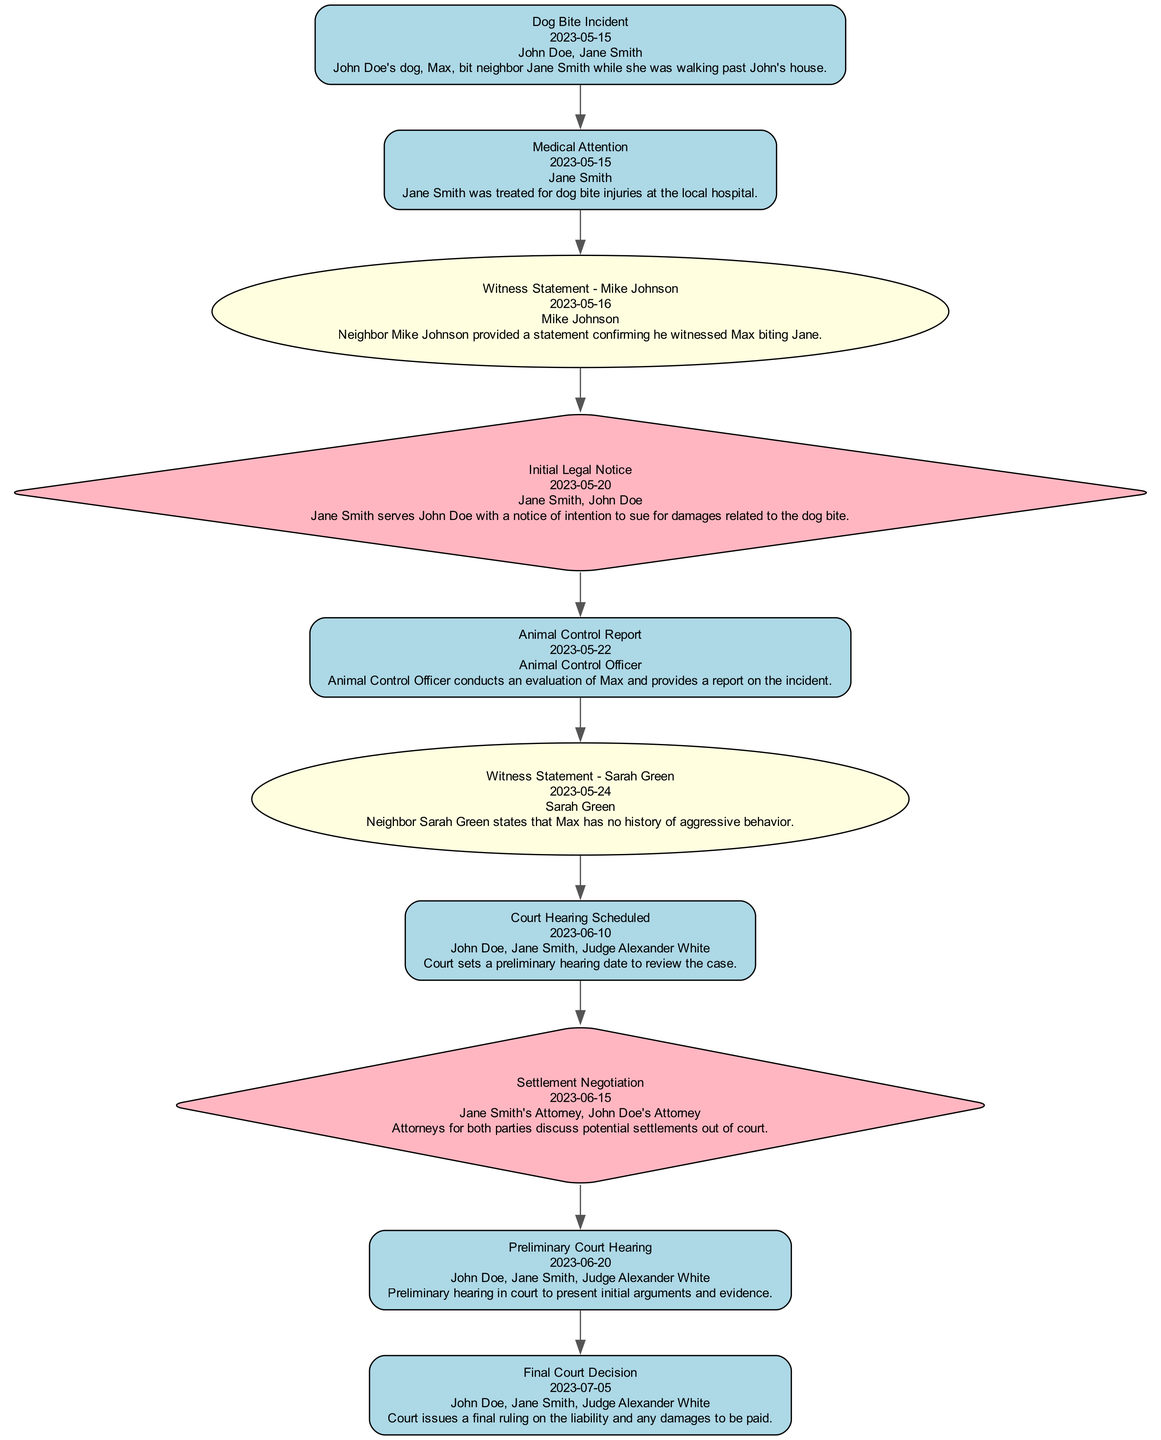What event occurred on May 15, 2023? The diagram indicates that the "Dog Bite Incident" occurred on this date, where John Doe's dog, Max, bit Jane Smith.
Answer: Dog Bite Incident Who provided a witness statement confirming the incident? According to the diagram, Mike Johnson provided a witness statement about the dog bite incident on May 16, 2023.
Answer: Mike Johnson What type of event took place on June 10, 2023? The diagram shows that a "Court Hearing Scheduled" event occurred on this date, indicating a legal proceeding related to the incident.
Answer: Court Hearing Scheduled How many witness testimonies are presented in the timeline? By examining the diagram, there are two witness testimonies mentioned: one from Mike Johnson and another from Sarah Green.
Answer: 2 What action did Jane Smith take on May 20, 2023? The diagram outlines that on May 20, 2023, Jane Smith served John Doe with a notice of intention to sue, indicating the start of legal action.
Answer: Initial Legal Notice What was the final decision date regarding the court case? The diagram specifies that the "Final Court Decision" was issued on July 5, 2023, detailing the outcome of the case.
Answer: July 5, 2023 Which party offered testimony that Max had no history of aggressive behavior? Sarah Green's testimony on May 24, 2023, confirmed that Max had no history of aggressive behavior, as indicated in the diagram.
Answer: Sarah Green What is the relationship between "Medical Attention" and the "Dog Bite Incident"? The diagram illustrates that the "Medical Attention" event directly follows the "Dog Bite Incident," indicating a response to injuries sustained in that incident.
Answer: Medical Attention How many legal actions have been documented in the timeline? The diagram shows two legal actions: the "Initial Legal Notice" on May 20, 2023, and "Settlement Negotiation" on June 15, 2023.
Answer: 2 